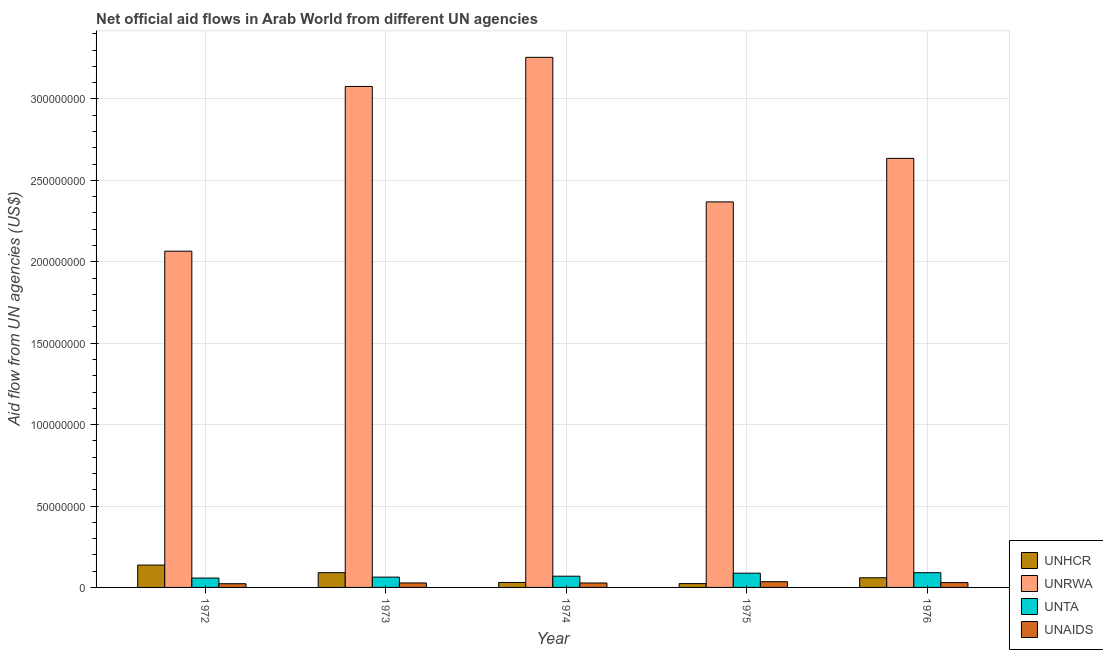How many different coloured bars are there?
Keep it short and to the point. 4. How many bars are there on the 2nd tick from the right?
Give a very brief answer. 4. What is the label of the 4th group of bars from the left?
Make the answer very short. 1975. What is the amount of aid given by unta in 1973?
Provide a succinct answer. 6.33e+06. Across all years, what is the maximum amount of aid given by unaids?
Ensure brevity in your answer.  3.53e+06. Across all years, what is the minimum amount of aid given by unhcr?
Your answer should be very brief. 2.35e+06. In which year was the amount of aid given by unrwa maximum?
Offer a terse response. 1974. In which year was the amount of aid given by unrwa minimum?
Give a very brief answer. 1972. What is the total amount of aid given by unrwa in the graph?
Provide a short and direct response. 1.34e+09. What is the difference between the amount of aid given by unta in 1973 and that in 1976?
Keep it short and to the point. -2.72e+06. What is the difference between the amount of aid given by unaids in 1974 and the amount of aid given by unrwa in 1973?
Provide a short and direct response. -2.00e+04. What is the average amount of aid given by unrwa per year?
Keep it short and to the point. 2.68e+08. What is the ratio of the amount of aid given by unrwa in 1972 to that in 1976?
Your response must be concise. 0.78. Is the difference between the amount of aid given by unta in 1973 and 1976 greater than the difference between the amount of aid given by unaids in 1973 and 1976?
Keep it short and to the point. No. What is the difference between the highest and the second highest amount of aid given by unhcr?
Give a very brief answer. 4.67e+06. What is the difference between the highest and the lowest amount of aid given by unta?
Your answer should be compact. 3.28e+06. What does the 2nd bar from the left in 1976 represents?
Your response must be concise. UNRWA. What does the 3rd bar from the right in 1974 represents?
Keep it short and to the point. UNRWA. Is it the case that in every year, the sum of the amount of aid given by unhcr and amount of aid given by unrwa is greater than the amount of aid given by unta?
Provide a succinct answer. Yes. How many bars are there?
Provide a succinct answer. 20. Are all the bars in the graph horizontal?
Your answer should be very brief. No. How many years are there in the graph?
Keep it short and to the point. 5. Are the values on the major ticks of Y-axis written in scientific E-notation?
Keep it short and to the point. No. How many legend labels are there?
Provide a succinct answer. 4. How are the legend labels stacked?
Your response must be concise. Vertical. What is the title of the graph?
Provide a succinct answer. Net official aid flows in Arab World from different UN agencies. Does "Debt policy" appear as one of the legend labels in the graph?
Offer a terse response. No. What is the label or title of the Y-axis?
Provide a succinct answer. Aid flow from UN agencies (US$). What is the Aid flow from UN agencies (US$) of UNHCR in 1972?
Provide a succinct answer. 1.37e+07. What is the Aid flow from UN agencies (US$) of UNRWA in 1972?
Keep it short and to the point. 2.07e+08. What is the Aid flow from UN agencies (US$) of UNTA in 1972?
Provide a short and direct response. 5.77e+06. What is the Aid flow from UN agencies (US$) of UNAIDS in 1972?
Make the answer very short. 2.28e+06. What is the Aid flow from UN agencies (US$) of UNHCR in 1973?
Provide a short and direct response. 9.06e+06. What is the Aid flow from UN agencies (US$) in UNRWA in 1973?
Offer a very short reply. 3.08e+08. What is the Aid flow from UN agencies (US$) of UNTA in 1973?
Ensure brevity in your answer.  6.33e+06. What is the Aid flow from UN agencies (US$) in UNAIDS in 1973?
Give a very brief answer. 2.74e+06. What is the Aid flow from UN agencies (US$) in UNHCR in 1974?
Offer a very short reply. 3.05e+06. What is the Aid flow from UN agencies (US$) of UNRWA in 1974?
Give a very brief answer. 3.26e+08. What is the Aid flow from UN agencies (US$) in UNTA in 1974?
Provide a short and direct response. 6.90e+06. What is the Aid flow from UN agencies (US$) of UNAIDS in 1974?
Provide a short and direct response. 2.72e+06. What is the Aid flow from UN agencies (US$) of UNHCR in 1975?
Provide a succinct answer. 2.35e+06. What is the Aid flow from UN agencies (US$) in UNRWA in 1975?
Your answer should be very brief. 2.37e+08. What is the Aid flow from UN agencies (US$) in UNTA in 1975?
Keep it short and to the point. 8.75e+06. What is the Aid flow from UN agencies (US$) in UNAIDS in 1975?
Offer a terse response. 3.53e+06. What is the Aid flow from UN agencies (US$) of UNHCR in 1976?
Keep it short and to the point. 5.94e+06. What is the Aid flow from UN agencies (US$) in UNRWA in 1976?
Your answer should be very brief. 2.64e+08. What is the Aid flow from UN agencies (US$) of UNTA in 1976?
Make the answer very short. 9.05e+06. What is the Aid flow from UN agencies (US$) in UNAIDS in 1976?
Provide a short and direct response. 2.97e+06. Across all years, what is the maximum Aid flow from UN agencies (US$) of UNHCR?
Offer a terse response. 1.37e+07. Across all years, what is the maximum Aid flow from UN agencies (US$) in UNRWA?
Your answer should be compact. 3.26e+08. Across all years, what is the maximum Aid flow from UN agencies (US$) of UNTA?
Your answer should be compact. 9.05e+06. Across all years, what is the maximum Aid flow from UN agencies (US$) in UNAIDS?
Ensure brevity in your answer.  3.53e+06. Across all years, what is the minimum Aid flow from UN agencies (US$) of UNHCR?
Make the answer very short. 2.35e+06. Across all years, what is the minimum Aid flow from UN agencies (US$) of UNRWA?
Provide a succinct answer. 2.07e+08. Across all years, what is the minimum Aid flow from UN agencies (US$) of UNTA?
Offer a very short reply. 5.77e+06. Across all years, what is the minimum Aid flow from UN agencies (US$) of UNAIDS?
Give a very brief answer. 2.28e+06. What is the total Aid flow from UN agencies (US$) of UNHCR in the graph?
Your answer should be very brief. 3.41e+07. What is the total Aid flow from UN agencies (US$) of UNRWA in the graph?
Give a very brief answer. 1.34e+09. What is the total Aid flow from UN agencies (US$) in UNTA in the graph?
Offer a very short reply. 3.68e+07. What is the total Aid flow from UN agencies (US$) of UNAIDS in the graph?
Make the answer very short. 1.42e+07. What is the difference between the Aid flow from UN agencies (US$) of UNHCR in 1972 and that in 1973?
Ensure brevity in your answer.  4.67e+06. What is the difference between the Aid flow from UN agencies (US$) in UNRWA in 1972 and that in 1973?
Give a very brief answer. -1.01e+08. What is the difference between the Aid flow from UN agencies (US$) of UNTA in 1972 and that in 1973?
Your answer should be very brief. -5.60e+05. What is the difference between the Aid flow from UN agencies (US$) in UNAIDS in 1972 and that in 1973?
Ensure brevity in your answer.  -4.60e+05. What is the difference between the Aid flow from UN agencies (US$) in UNHCR in 1972 and that in 1974?
Offer a very short reply. 1.07e+07. What is the difference between the Aid flow from UN agencies (US$) of UNRWA in 1972 and that in 1974?
Ensure brevity in your answer.  -1.19e+08. What is the difference between the Aid flow from UN agencies (US$) in UNTA in 1972 and that in 1974?
Your response must be concise. -1.13e+06. What is the difference between the Aid flow from UN agencies (US$) in UNAIDS in 1972 and that in 1974?
Your answer should be very brief. -4.40e+05. What is the difference between the Aid flow from UN agencies (US$) in UNHCR in 1972 and that in 1975?
Your answer should be compact. 1.14e+07. What is the difference between the Aid flow from UN agencies (US$) of UNRWA in 1972 and that in 1975?
Your answer should be very brief. -3.03e+07. What is the difference between the Aid flow from UN agencies (US$) in UNTA in 1972 and that in 1975?
Ensure brevity in your answer.  -2.98e+06. What is the difference between the Aid flow from UN agencies (US$) in UNAIDS in 1972 and that in 1975?
Your answer should be very brief. -1.25e+06. What is the difference between the Aid flow from UN agencies (US$) in UNHCR in 1972 and that in 1976?
Give a very brief answer. 7.79e+06. What is the difference between the Aid flow from UN agencies (US$) in UNRWA in 1972 and that in 1976?
Offer a very short reply. -5.70e+07. What is the difference between the Aid flow from UN agencies (US$) of UNTA in 1972 and that in 1976?
Your answer should be compact. -3.28e+06. What is the difference between the Aid flow from UN agencies (US$) of UNAIDS in 1972 and that in 1976?
Provide a short and direct response. -6.90e+05. What is the difference between the Aid flow from UN agencies (US$) of UNHCR in 1973 and that in 1974?
Make the answer very short. 6.01e+06. What is the difference between the Aid flow from UN agencies (US$) in UNRWA in 1973 and that in 1974?
Offer a terse response. -1.79e+07. What is the difference between the Aid flow from UN agencies (US$) of UNTA in 1973 and that in 1974?
Your answer should be very brief. -5.70e+05. What is the difference between the Aid flow from UN agencies (US$) of UNAIDS in 1973 and that in 1974?
Your answer should be compact. 2.00e+04. What is the difference between the Aid flow from UN agencies (US$) in UNHCR in 1973 and that in 1975?
Give a very brief answer. 6.71e+06. What is the difference between the Aid flow from UN agencies (US$) in UNRWA in 1973 and that in 1975?
Your answer should be compact. 7.09e+07. What is the difference between the Aid flow from UN agencies (US$) in UNTA in 1973 and that in 1975?
Offer a very short reply. -2.42e+06. What is the difference between the Aid flow from UN agencies (US$) in UNAIDS in 1973 and that in 1975?
Give a very brief answer. -7.90e+05. What is the difference between the Aid flow from UN agencies (US$) of UNHCR in 1973 and that in 1976?
Give a very brief answer. 3.12e+06. What is the difference between the Aid flow from UN agencies (US$) of UNRWA in 1973 and that in 1976?
Your response must be concise. 4.42e+07. What is the difference between the Aid flow from UN agencies (US$) in UNTA in 1973 and that in 1976?
Provide a succinct answer. -2.72e+06. What is the difference between the Aid flow from UN agencies (US$) in UNAIDS in 1973 and that in 1976?
Your answer should be compact. -2.30e+05. What is the difference between the Aid flow from UN agencies (US$) of UNHCR in 1974 and that in 1975?
Ensure brevity in your answer.  7.00e+05. What is the difference between the Aid flow from UN agencies (US$) of UNRWA in 1974 and that in 1975?
Give a very brief answer. 8.88e+07. What is the difference between the Aid flow from UN agencies (US$) in UNTA in 1974 and that in 1975?
Provide a succinct answer. -1.85e+06. What is the difference between the Aid flow from UN agencies (US$) of UNAIDS in 1974 and that in 1975?
Your answer should be compact. -8.10e+05. What is the difference between the Aid flow from UN agencies (US$) in UNHCR in 1974 and that in 1976?
Make the answer very short. -2.89e+06. What is the difference between the Aid flow from UN agencies (US$) of UNRWA in 1974 and that in 1976?
Your answer should be very brief. 6.20e+07. What is the difference between the Aid flow from UN agencies (US$) in UNTA in 1974 and that in 1976?
Your answer should be very brief. -2.15e+06. What is the difference between the Aid flow from UN agencies (US$) in UNHCR in 1975 and that in 1976?
Provide a succinct answer. -3.59e+06. What is the difference between the Aid flow from UN agencies (US$) in UNRWA in 1975 and that in 1976?
Offer a terse response. -2.67e+07. What is the difference between the Aid flow from UN agencies (US$) in UNTA in 1975 and that in 1976?
Keep it short and to the point. -3.00e+05. What is the difference between the Aid flow from UN agencies (US$) of UNAIDS in 1975 and that in 1976?
Ensure brevity in your answer.  5.60e+05. What is the difference between the Aid flow from UN agencies (US$) of UNHCR in 1972 and the Aid flow from UN agencies (US$) of UNRWA in 1973?
Offer a very short reply. -2.94e+08. What is the difference between the Aid flow from UN agencies (US$) of UNHCR in 1972 and the Aid flow from UN agencies (US$) of UNTA in 1973?
Your answer should be very brief. 7.40e+06. What is the difference between the Aid flow from UN agencies (US$) of UNHCR in 1972 and the Aid flow from UN agencies (US$) of UNAIDS in 1973?
Your response must be concise. 1.10e+07. What is the difference between the Aid flow from UN agencies (US$) in UNRWA in 1972 and the Aid flow from UN agencies (US$) in UNTA in 1973?
Offer a terse response. 2.00e+08. What is the difference between the Aid flow from UN agencies (US$) of UNRWA in 1972 and the Aid flow from UN agencies (US$) of UNAIDS in 1973?
Your response must be concise. 2.04e+08. What is the difference between the Aid flow from UN agencies (US$) in UNTA in 1972 and the Aid flow from UN agencies (US$) in UNAIDS in 1973?
Keep it short and to the point. 3.03e+06. What is the difference between the Aid flow from UN agencies (US$) in UNHCR in 1972 and the Aid flow from UN agencies (US$) in UNRWA in 1974?
Provide a short and direct response. -3.12e+08. What is the difference between the Aid flow from UN agencies (US$) in UNHCR in 1972 and the Aid flow from UN agencies (US$) in UNTA in 1974?
Give a very brief answer. 6.83e+06. What is the difference between the Aid flow from UN agencies (US$) of UNHCR in 1972 and the Aid flow from UN agencies (US$) of UNAIDS in 1974?
Keep it short and to the point. 1.10e+07. What is the difference between the Aid flow from UN agencies (US$) of UNRWA in 1972 and the Aid flow from UN agencies (US$) of UNTA in 1974?
Offer a terse response. 2.00e+08. What is the difference between the Aid flow from UN agencies (US$) of UNRWA in 1972 and the Aid flow from UN agencies (US$) of UNAIDS in 1974?
Your answer should be compact. 2.04e+08. What is the difference between the Aid flow from UN agencies (US$) of UNTA in 1972 and the Aid flow from UN agencies (US$) of UNAIDS in 1974?
Your response must be concise. 3.05e+06. What is the difference between the Aid flow from UN agencies (US$) in UNHCR in 1972 and the Aid flow from UN agencies (US$) in UNRWA in 1975?
Your answer should be compact. -2.23e+08. What is the difference between the Aid flow from UN agencies (US$) in UNHCR in 1972 and the Aid flow from UN agencies (US$) in UNTA in 1975?
Your answer should be compact. 4.98e+06. What is the difference between the Aid flow from UN agencies (US$) in UNHCR in 1972 and the Aid flow from UN agencies (US$) in UNAIDS in 1975?
Provide a short and direct response. 1.02e+07. What is the difference between the Aid flow from UN agencies (US$) in UNRWA in 1972 and the Aid flow from UN agencies (US$) in UNTA in 1975?
Offer a terse response. 1.98e+08. What is the difference between the Aid flow from UN agencies (US$) of UNRWA in 1972 and the Aid flow from UN agencies (US$) of UNAIDS in 1975?
Provide a short and direct response. 2.03e+08. What is the difference between the Aid flow from UN agencies (US$) in UNTA in 1972 and the Aid flow from UN agencies (US$) in UNAIDS in 1975?
Make the answer very short. 2.24e+06. What is the difference between the Aid flow from UN agencies (US$) of UNHCR in 1972 and the Aid flow from UN agencies (US$) of UNRWA in 1976?
Offer a very short reply. -2.50e+08. What is the difference between the Aid flow from UN agencies (US$) of UNHCR in 1972 and the Aid flow from UN agencies (US$) of UNTA in 1976?
Provide a succinct answer. 4.68e+06. What is the difference between the Aid flow from UN agencies (US$) in UNHCR in 1972 and the Aid flow from UN agencies (US$) in UNAIDS in 1976?
Make the answer very short. 1.08e+07. What is the difference between the Aid flow from UN agencies (US$) in UNRWA in 1972 and the Aid flow from UN agencies (US$) in UNTA in 1976?
Your response must be concise. 1.97e+08. What is the difference between the Aid flow from UN agencies (US$) in UNRWA in 1972 and the Aid flow from UN agencies (US$) in UNAIDS in 1976?
Make the answer very short. 2.04e+08. What is the difference between the Aid flow from UN agencies (US$) in UNTA in 1972 and the Aid flow from UN agencies (US$) in UNAIDS in 1976?
Make the answer very short. 2.80e+06. What is the difference between the Aid flow from UN agencies (US$) of UNHCR in 1973 and the Aid flow from UN agencies (US$) of UNRWA in 1974?
Give a very brief answer. -3.17e+08. What is the difference between the Aid flow from UN agencies (US$) in UNHCR in 1973 and the Aid flow from UN agencies (US$) in UNTA in 1974?
Offer a terse response. 2.16e+06. What is the difference between the Aid flow from UN agencies (US$) of UNHCR in 1973 and the Aid flow from UN agencies (US$) of UNAIDS in 1974?
Ensure brevity in your answer.  6.34e+06. What is the difference between the Aid flow from UN agencies (US$) in UNRWA in 1973 and the Aid flow from UN agencies (US$) in UNTA in 1974?
Keep it short and to the point. 3.01e+08. What is the difference between the Aid flow from UN agencies (US$) in UNRWA in 1973 and the Aid flow from UN agencies (US$) in UNAIDS in 1974?
Keep it short and to the point. 3.05e+08. What is the difference between the Aid flow from UN agencies (US$) in UNTA in 1973 and the Aid flow from UN agencies (US$) in UNAIDS in 1974?
Make the answer very short. 3.61e+06. What is the difference between the Aid flow from UN agencies (US$) of UNHCR in 1973 and the Aid flow from UN agencies (US$) of UNRWA in 1975?
Provide a short and direct response. -2.28e+08. What is the difference between the Aid flow from UN agencies (US$) of UNHCR in 1973 and the Aid flow from UN agencies (US$) of UNTA in 1975?
Provide a succinct answer. 3.10e+05. What is the difference between the Aid flow from UN agencies (US$) in UNHCR in 1973 and the Aid flow from UN agencies (US$) in UNAIDS in 1975?
Your answer should be compact. 5.53e+06. What is the difference between the Aid flow from UN agencies (US$) of UNRWA in 1973 and the Aid flow from UN agencies (US$) of UNTA in 1975?
Make the answer very short. 2.99e+08. What is the difference between the Aid flow from UN agencies (US$) in UNRWA in 1973 and the Aid flow from UN agencies (US$) in UNAIDS in 1975?
Ensure brevity in your answer.  3.04e+08. What is the difference between the Aid flow from UN agencies (US$) of UNTA in 1973 and the Aid flow from UN agencies (US$) of UNAIDS in 1975?
Offer a very short reply. 2.80e+06. What is the difference between the Aid flow from UN agencies (US$) in UNHCR in 1973 and the Aid flow from UN agencies (US$) in UNRWA in 1976?
Make the answer very short. -2.54e+08. What is the difference between the Aid flow from UN agencies (US$) in UNHCR in 1973 and the Aid flow from UN agencies (US$) in UNTA in 1976?
Ensure brevity in your answer.  10000. What is the difference between the Aid flow from UN agencies (US$) in UNHCR in 1973 and the Aid flow from UN agencies (US$) in UNAIDS in 1976?
Your answer should be very brief. 6.09e+06. What is the difference between the Aid flow from UN agencies (US$) of UNRWA in 1973 and the Aid flow from UN agencies (US$) of UNTA in 1976?
Provide a short and direct response. 2.99e+08. What is the difference between the Aid flow from UN agencies (US$) of UNRWA in 1973 and the Aid flow from UN agencies (US$) of UNAIDS in 1976?
Give a very brief answer. 3.05e+08. What is the difference between the Aid flow from UN agencies (US$) in UNTA in 1973 and the Aid flow from UN agencies (US$) in UNAIDS in 1976?
Your answer should be compact. 3.36e+06. What is the difference between the Aid flow from UN agencies (US$) in UNHCR in 1974 and the Aid flow from UN agencies (US$) in UNRWA in 1975?
Give a very brief answer. -2.34e+08. What is the difference between the Aid flow from UN agencies (US$) of UNHCR in 1974 and the Aid flow from UN agencies (US$) of UNTA in 1975?
Your response must be concise. -5.70e+06. What is the difference between the Aid flow from UN agencies (US$) in UNHCR in 1974 and the Aid flow from UN agencies (US$) in UNAIDS in 1975?
Your answer should be very brief. -4.80e+05. What is the difference between the Aid flow from UN agencies (US$) in UNRWA in 1974 and the Aid flow from UN agencies (US$) in UNTA in 1975?
Give a very brief answer. 3.17e+08. What is the difference between the Aid flow from UN agencies (US$) of UNRWA in 1974 and the Aid flow from UN agencies (US$) of UNAIDS in 1975?
Keep it short and to the point. 3.22e+08. What is the difference between the Aid flow from UN agencies (US$) of UNTA in 1974 and the Aid flow from UN agencies (US$) of UNAIDS in 1975?
Make the answer very short. 3.37e+06. What is the difference between the Aid flow from UN agencies (US$) in UNHCR in 1974 and the Aid flow from UN agencies (US$) in UNRWA in 1976?
Offer a very short reply. -2.60e+08. What is the difference between the Aid flow from UN agencies (US$) in UNHCR in 1974 and the Aid flow from UN agencies (US$) in UNTA in 1976?
Give a very brief answer. -6.00e+06. What is the difference between the Aid flow from UN agencies (US$) of UNRWA in 1974 and the Aid flow from UN agencies (US$) of UNTA in 1976?
Offer a very short reply. 3.17e+08. What is the difference between the Aid flow from UN agencies (US$) of UNRWA in 1974 and the Aid flow from UN agencies (US$) of UNAIDS in 1976?
Make the answer very short. 3.23e+08. What is the difference between the Aid flow from UN agencies (US$) in UNTA in 1974 and the Aid flow from UN agencies (US$) in UNAIDS in 1976?
Your response must be concise. 3.93e+06. What is the difference between the Aid flow from UN agencies (US$) of UNHCR in 1975 and the Aid flow from UN agencies (US$) of UNRWA in 1976?
Your answer should be compact. -2.61e+08. What is the difference between the Aid flow from UN agencies (US$) of UNHCR in 1975 and the Aid flow from UN agencies (US$) of UNTA in 1976?
Your answer should be very brief. -6.70e+06. What is the difference between the Aid flow from UN agencies (US$) of UNHCR in 1975 and the Aid flow from UN agencies (US$) of UNAIDS in 1976?
Make the answer very short. -6.20e+05. What is the difference between the Aid flow from UN agencies (US$) of UNRWA in 1975 and the Aid flow from UN agencies (US$) of UNTA in 1976?
Keep it short and to the point. 2.28e+08. What is the difference between the Aid flow from UN agencies (US$) of UNRWA in 1975 and the Aid flow from UN agencies (US$) of UNAIDS in 1976?
Offer a terse response. 2.34e+08. What is the difference between the Aid flow from UN agencies (US$) in UNTA in 1975 and the Aid flow from UN agencies (US$) in UNAIDS in 1976?
Your answer should be compact. 5.78e+06. What is the average Aid flow from UN agencies (US$) of UNHCR per year?
Your response must be concise. 6.83e+06. What is the average Aid flow from UN agencies (US$) of UNRWA per year?
Provide a short and direct response. 2.68e+08. What is the average Aid flow from UN agencies (US$) of UNTA per year?
Make the answer very short. 7.36e+06. What is the average Aid flow from UN agencies (US$) of UNAIDS per year?
Your answer should be compact. 2.85e+06. In the year 1972, what is the difference between the Aid flow from UN agencies (US$) of UNHCR and Aid flow from UN agencies (US$) of UNRWA?
Provide a short and direct response. -1.93e+08. In the year 1972, what is the difference between the Aid flow from UN agencies (US$) in UNHCR and Aid flow from UN agencies (US$) in UNTA?
Ensure brevity in your answer.  7.96e+06. In the year 1972, what is the difference between the Aid flow from UN agencies (US$) of UNHCR and Aid flow from UN agencies (US$) of UNAIDS?
Provide a short and direct response. 1.14e+07. In the year 1972, what is the difference between the Aid flow from UN agencies (US$) of UNRWA and Aid flow from UN agencies (US$) of UNTA?
Give a very brief answer. 2.01e+08. In the year 1972, what is the difference between the Aid flow from UN agencies (US$) in UNRWA and Aid flow from UN agencies (US$) in UNAIDS?
Give a very brief answer. 2.04e+08. In the year 1972, what is the difference between the Aid flow from UN agencies (US$) of UNTA and Aid flow from UN agencies (US$) of UNAIDS?
Ensure brevity in your answer.  3.49e+06. In the year 1973, what is the difference between the Aid flow from UN agencies (US$) in UNHCR and Aid flow from UN agencies (US$) in UNRWA?
Provide a short and direct response. -2.99e+08. In the year 1973, what is the difference between the Aid flow from UN agencies (US$) in UNHCR and Aid flow from UN agencies (US$) in UNTA?
Offer a terse response. 2.73e+06. In the year 1973, what is the difference between the Aid flow from UN agencies (US$) of UNHCR and Aid flow from UN agencies (US$) of UNAIDS?
Your answer should be compact. 6.32e+06. In the year 1973, what is the difference between the Aid flow from UN agencies (US$) in UNRWA and Aid flow from UN agencies (US$) in UNTA?
Give a very brief answer. 3.01e+08. In the year 1973, what is the difference between the Aid flow from UN agencies (US$) in UNRWA and Aid flow from UN agencies (US$) in UNAIDS?
Provide a short and direct response. 3.05e+08. In the year 1973, what is the difference between the Aid flow from UN agencies (US$) of UNTA and Aid flow from UN agencies (US$) of UNAIDS?
Your answer should be very brief. 3.59e+06. In the year 1974, what is the difference between the Aid flow from UN agencies (US$) in UNHCR and Aid flow from UN agencies (US$) in UNRWA?
Keep it short and to the point. -3.23e+08. In the year 1974, what is the difference between the Aid flow from UN agencies (US$) in UNHCR and Aid flow from UN agencies (US$) in UNTA?
Offer a very short reply. -3.85e+06. In the year 1974, what is the difference between the Aid flow from UN agencies (US$) of UNHCR and Aid flow from UN agencies (US$) of UNAIDS?
Your response must be concise. 3.30e+05. In the year 1974, what is the difference between the Aid flow from UN agencies (US$) in UNRWA and Aid flow from UN agencies (US$) in UNTA?
Your answer should be compact. 3.19e+08. In the year 1974, what is the difference between the Aid flow from UN agencies (US$) of UNRWA and Aid flow from UN agencies (US$) of UNAIDS?
Offer a terse response. 3.23e+08. In the year 1974, what is the difference between the Aid flow from UN agencies (US$) in UNTA and Aid flow from UN agencies (US$) in UNAIDS?
Keep it short and to the point. 4.18e+06. In the year 1975, what is the difference between the Aid flow from UN agencies (US$) in UNHCR and Aid flow from UN agencies (US$) in UNRWA?
Offer a terse response. -2.34e+08. In the year 1975, what is the difference between the Aid flow from UN agencies (US$) of UNHCR and Aid flow from UN agencies (US$) of UNTA?
Provide a short and direct response. -6.40e+06. In the year 1975, what is the difference between the Aid flow from UN agencies (US$) of UNHCR and Aid flow from UN agencies (US$) of UNAIDS?
Provide a succinct answer. -1.18e+06. In the year 1975, what is the difference between the Aid flow from UN agencies (US$) of UNRWA and Aid flow from UN agencies (US$) of UNTA?
Offer a very short reply. 2.28e+08. In the year 1975, what is the difference between the Aid flow from UN agencies (US$) of UNRWA and Aid flow from UN agencies (US$) of UNAIDS?
Your response must be concise. 2.33e+08. In the year 1975, what is the difference between the Aid flow from UN agencies (US$) in UNTA and Aid flow from UN agencies (US$) in UNAIDS?
Make the answer very short. 5.22e+06. In the year 1976, what is the difference between the Aid flow from UN agencies (US$) in UNHCR and Aid flow from UN agencies (US$) in UNRWA?
Ensure brevity in your answer.  -2.58e+08. In the year 1976, what is the difference between the Aid flow from UN agencies (US$) of UNHCR and Aid flow from UN agencies (US$) of UNTA?
Provide a succinct answer. -3.11e+06. In the year 1976, what is the difference between the Aid flow from UN agencies (US$) in UNHCR and Aid flow from UN agencies (US$) in UNAIDS?
Ensure brevity in your answer.  2.97e+06. In the year 1976, what is the difference between the Aid flow from UN agencies (US$) of UNRWA and Aid flow from UN agencies (US$) of UNTA?
Offer a terse response. 2.54e+08. In the year 1976, what is the difference between the Aid flow from UN agencies (US$) in UNRWA and Aid flow from UN agencies (US$) in UNAIDS?
Keep it short and to the point. 2.61e+08. In the year 1976, what is the difference between the Aid flow from UN agencies (US$) of UNTA and Aid flow from UN agencies (US$) of UNAIDS?
Offer a terse response. 6.08e+06. What is the ratio of the Aid flow from UN agencies (US$) in UNHCR in 1972 to that in 1973?
Ensure brevity in your answer.  1.52. What is the ratio of the Aid flow from UN agencies (US$) of UNRWA in 1972 to that in 1973?
Offer a very short reply. 0.67. What is the ratio of the Aid flow from UN agencies (US$) of UNTA in 1972 to that in 1973?
Your answer should be compact. 0.91. What is the ratio of the Aid flow from UN agencies (US$) of UNAIDS in 1972 to that in 1973?
Provide a succinct answer. 0.83. What is the ratio of the Aid flow from UN agencies (US$) in UNHCR in 1972 to that in 1974?
Provide a succinct answer. 4.5. What is the ratio of the Aid flow from UN agencies (US$) in UNRWA in 1972 to that in 1974?
Offer a terse response. 0.63. What is the ratio of the Aid flow from UN agencies (US$) in UNTA in 1972 to that in 1974?
Offer a very short reply. 0.84. What is the ratio of the Aid flow from UN agencies (US$) in UNAIDS in 1972 to that in 1974?
Your response must be concise. 0.84. What is the ratio of the Aid flow from UN agencies (US$) of UNHCR in 1972 to that in 1975?
Keep it short and to the point. 5.84. What is the ratio of the Aid flow from UN agencies (US$) of UNRWA in 1972 to that in 1975?
Your answer should be compact. 0.87. What is the ratio of the Aid flow from UN agencies (US$) in UNTA in 1972 to that in 1975?
Give a very brief answer. 0.66. What is the ratio of the Aid flow from UN agencies (US$) in UNAIDS in 1972 to that in 1975?
Ensure brevity in your answer.  0.65. What is the ratio of the Aid flow from UN agencies (US$) in UNHCR in 1972 to that in 1976?
Offer a terse response. 2.31. What is the ratio of the Aid flow from UN agencies (US$) in UNRWA in 1972 to that in 1976?
Ensure brevity in your answer.  0.78. What is the ratio of the Aid flow from UN agencies (US$) of UNTA in 1972 to that in 1976?
Provide a succinct answer. 0.64. What is the ratio of the Aid flow from UN agencies (US$) in UNAIDS in 1972 to that in 1976?
Your answer should be very brief. 0.77. What is the ratio of the Aid flow from UN agencies (US$) in UNHCR in 1973 to that in 1974?
Give a very brief answer. 2.97. What is the ratio of the Aid flow from UN agencies (US$) of UNRWA in 1973 to that in 1974?
Offer a very short reply. 0.95. What is the ratio of the Aid flow from UN agencies (US$) of UNTA in 1973 to that in 1974?
Keep it short and to the point. 0.92. What is the ratio of the Aid flow from UN agencies (US$) in UNAIDS in 1973 to that in 1974?
Your answer should be very brief. 1.01. What is the ratio of the Aid flow from UN agencies (US$) in UNHCR in 1973 to that in 1975?
Ensure brevity in your answer.  3.86. What is the ratio of the Aid flow from UN agencies (US$) in UNRWA in 1973 to that in 1975?
Offer a terse response. 1.3. What is the ratio of the Aid flow from UN agencies (US$) in UNTA in 1973 to that in 1975?
Offer a very short reply. 0.72. What is the ratio of the Aid flow from UN agencies (US$) of UNAIDS in 1973 to that in 1975?
Provide a short and direct response. 0.78. What is the ratio of the Aid flow from UN agencies (US$) in UNHCR in 1973 to that in 1976?
Give a very brief answer. 1.53. What is the ratio of the Aid flow from UN agencies (US$) in UNRWA in 1973 to that in 1976?
Make the answer very short. 1.17. What is the ratio of the Aid flow from UN agencies (US$) of UNTA in 1973 to that in 1976?
Your answer should be compact. 0.7. What is the ratio of the Aid flow from UN agencies (US$) of UNAIDS in 1973 to that in 1976?
Offer a terse response. 0.92. What is the ratio of the Aid flow from UN agencies (US$) in UNHCR in 1974 to that in 1975?
Provide a succinct answer. 1.3. What is the ratio of the Aid flow from UN agencies (US$) of UNRWA in 1974 to that in 1975?
Offer a terse response. 1.38. What is the ratio of the Aid flow from UN agencies (US$) of UNTA in 1974 to that in 1975?
Your answer should be very brief. 0.79. What is the ratio of the Aid flow from UN agencies (US$) in UNAIDS in 1974 to that in 1975?
Provide a short and direct response. 0.77. What is the ratio of the Aid flow from UN agencies (US$) in UNHCR in 1974 to that in 1976?
Make the answer very short. 0.51. What is the ratio of the Aid flow from UN agencies (US$) in UNRWA in 1974 to that in 1976?
Your answer should be very brief. 1.24. What is the ratio of the Aid flow from UN agencies (US$) of UNTA in 1974 to that in 1976?
Offer a terse response. 0.76. What is the ratio of the Aid flow from UN agencies (US$) of UNAIDS in 1974 to that in 1976?
Your response must be concise. 0.92. What is the ratio of the Aid flow from UN agencies (US$) of UNHCR in 1975 to that in 1976?
Your response must be concise. 0.4. What is the ratio of the Aid flow from UN agencies (US$) of UNRWA in 1975 to that in 1976?
Your answer should be very brief. 0.9. What is the ratio of the Aid flow from UN agencies (US$) of UNTA in 1975 to that in 1976?
Your answer should be compact. 0.97. What is the ratio of the Aid flow from UN agencies (US$) in UNAIDS in 1975 to that in 1976?
Ensure brevity in your answer.  1.19. What is the difference between the highest and the second highest Aid flow from UN agencies (US$) in UNHCR?
Your response must be concise. 4.67e+06. What is the difference between the highest and the second highest Aid flow from UN agencies (US$) of UNRWA?
Ensure brevity in your answer.  1.79e+07. What is the difference between the highest and the second highest Aid flow from UN agencies (US$) of UNAIDS?
Ensure brevity in your answer.  5.60e+05. What is the difference between the highest and the lowest Aid flow from UN agencies (US$) of UNHCR?
Provide a succinct answer. 1.14e+07. What is the difference between the highest and the lowest Aid flow from UN agencies (US$) in UNRWA?
Provide a short and direct response. 1.19e+08. What is the difference between the highest and the lowest Aid flow from UN agencies (US$) of UNTA?
Your response must be concise. 3.28e+06. What is the difference between the highest and the lowest Aid flow from UN agencies (US$) of UNAIDS?
Your answer should be compact. 1.25e+06. 